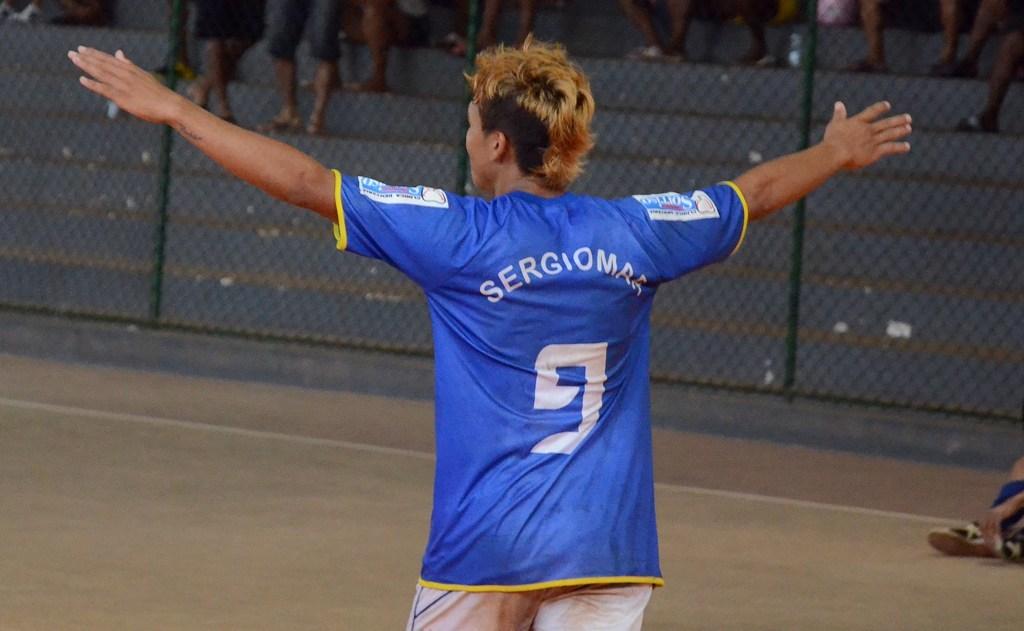What is the name of player number 9?
Your answer should be compact. Sergiomar. What number is on her shirt?
Give a very brief answer. 9. 